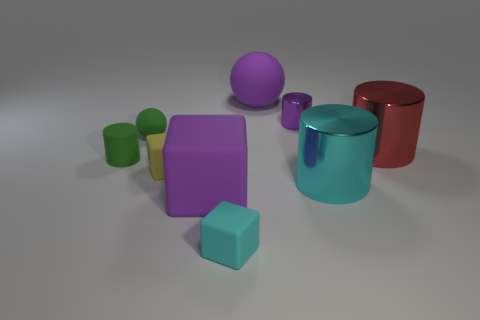How many cyan metallic objects have the same size as the red metallic object?
Offer a very short reply. 1. Do the cyan thing on the left side of the large purple sphere and the ball that is left of the purple matte ball have the same material?
Make the answer very short. Yes. What material is the large purple thing that is in front of the large rubber thing that is behind the red thing?
Provide a short and direct response. Rubber. There is a large purple thing in front of the small purple shiny object; what is its material?
Offer a terse response. Rubber. What number of other cyan things are the same shape as the small shiny object?
Ensure brevity in your answer.  1. Is the small metallic cylinder the same color as the rubber cylinder?
Make the answer very short. No. What is the material of the cylinder to the left of the sphere that is to the left of the matte thing behind the small purple cylinder?
Provide a short and direct response. Rubber. There is a small metal object; are there any big purple rubber spheres in front of it?
Offer a very short reply. No. What shape is the purple shiny object that is the same size as the green ball?
Keep it short and to the point. Cylinder. Is the purple cylinder made of the same material as the small cyan block?
Your answer should be compact. No. 